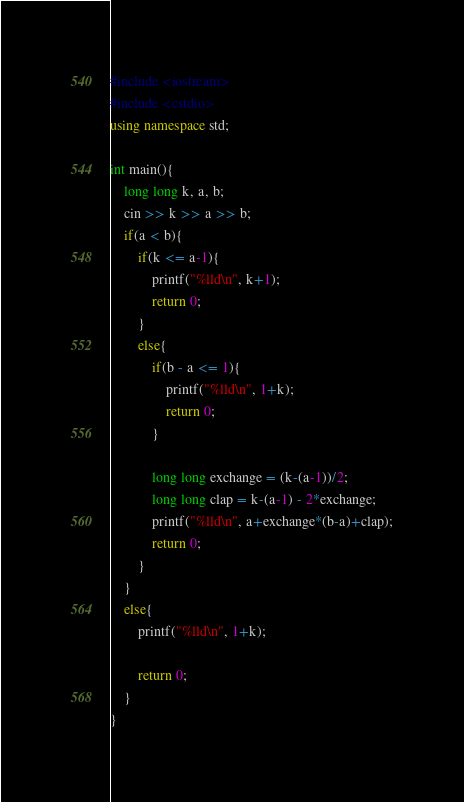<code> <loc_0><loc_0><loc_500><loc_500><_C++_>#include <iostream>
#include <cstdio>
using namespace std;

int main(){
    long long k, a, b;
    cin >> k >> a >> b;
    if(a < b){
        if(k <= a-1){
            printf("%lld\n", k+1);
            return 0;
        }
        else{
            if(b - a <= 1){
                printf("%lld\n", 1+k);
                return 0;
            }
            
            long long exchange = (k-(a-1))/2;
            long long clap = k-(a-1) - 2*exchange;
            printf("%lld\n", a+exchange*(b-a)+clap);
            return 0;
        }
    }
    else{
        printf("%lld\n", 1+k);

        return 0;
    }
}</code> 